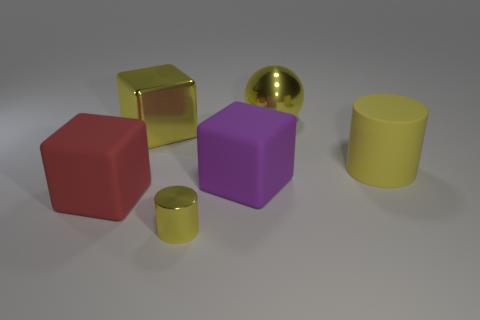Subtract all purple cubes. How many cubes are left? 2 Add 2 yellow rubber things. How many objects exist? 8 Subtract all red blocks. How many blocks are left? 2 Subtract all spheres. How many objects are left? 5 Subtract all gray cylinders. Subtract all gray blocks. How many cylinders are left? 2 Subtract all big yellow spheres. Subtract all big metal blocks. How many objects are left? 4 Add 6 red objects. How many red objects are left? 7 Add 1 brown metal blocks. How many brown metal blocks exist? 1 Subtract 1 yellow cylinders. How many objects are left? 5 